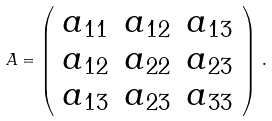<formula> <loc_0><loc_0><loc_500><loc_500>A = \left ( \begin{array} { c c c } a _ { 1 1 } & a _ { 1 2 } & a _ { 1 3 } \\ a _ { 1 2 } & a _ { 2 2 } & a _ { 2 3 } \\ a _ { 1 3 } & a _ { 2 3 } & a _ { 3 3 } \\ \end{array} \right ) \, .</formula> 